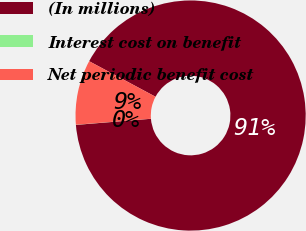Convert chart. <chart><loc_0><loc_0><loc_500><loc_500><pie_chart><fcel>(In millions)<fcel>Interest cost on benefit<fcel>Net periodic benefit cost<nl><fcel>90.88%<fcel>0.02%<fcel>9.1%<nl></chart> 